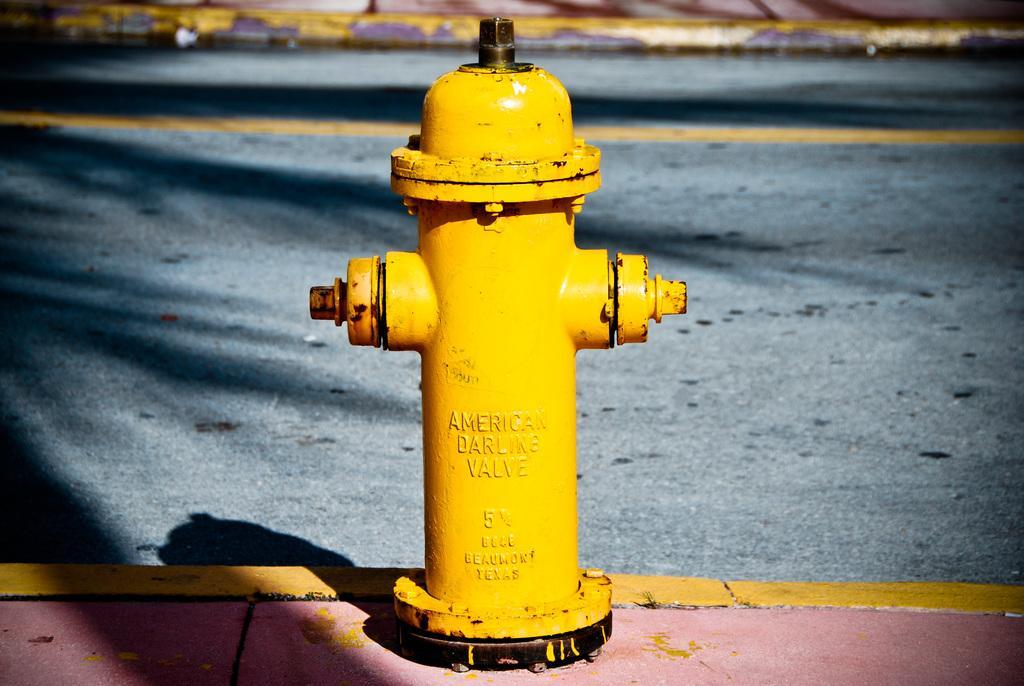Can you describe this image briefly? This picture is clicked outside. In the center we can see text on the yellow color water hydrant. In the background we can see the concrete road and the shadows of some objects on the road. 